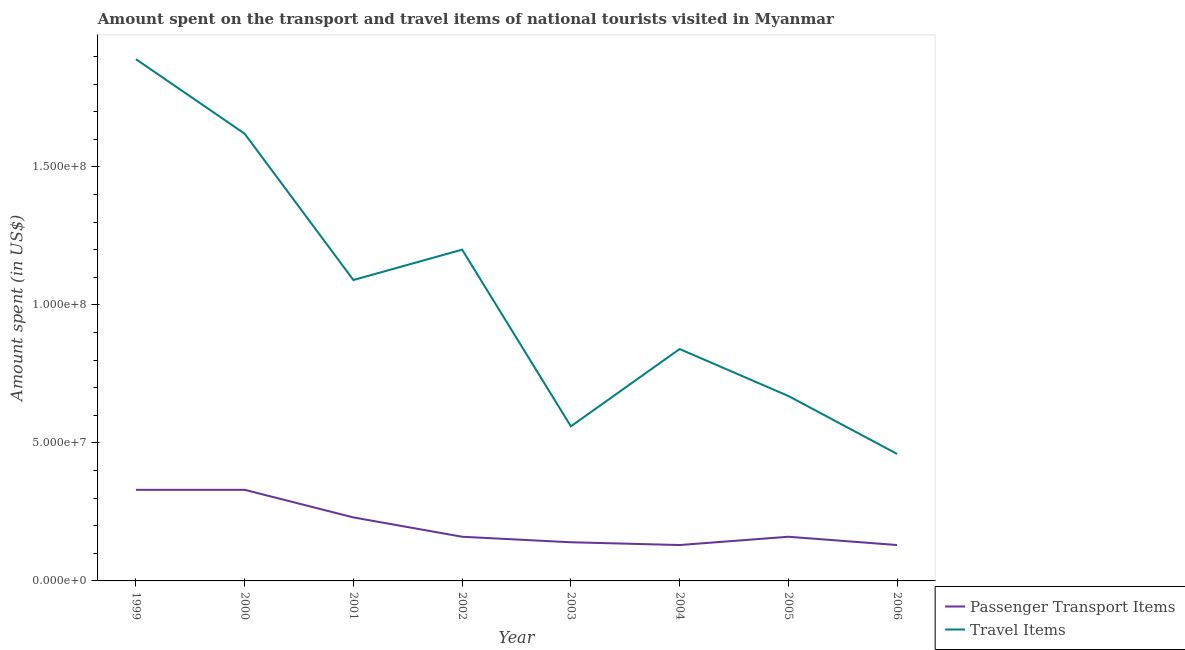How many different coloured lines are there?
Make the answer very short. 2. What is the amount spent on passenger transport items in 2006?
Provide a short and direct response. 1.30e+07. Across all years, what is the maximum amount spent in travel items?
Provide a short and direct response. 1.89e+08. Across all years, what is the minimum amount spent in travel items?
Your response must be concise. 4.60e+07. In which year was the amount spent in travel items maximum?
Keep it short and to the point. 1999. What is the total amount spent on passenger transport items in the graph?
Provide a succinct answer. 1.61e+08. What is the difference between the amount spent in travel items in 2000 and that in 2001?
Keep it short and to the point. 5.30e+07. What is the difference between the amount spent on passenger transport items in 2002 and the amount spent in travel items in 2005?
Keep it short and to the point. -5.10e+07. What is the average amount spent on passenger transport items per year?
Ensure brevity in your answer.  2.01e+07. In the year 2006, what is the difference between the amount spent on passenger transport items and amount spent in travel items?
Ensure brevity in your answer.  -3.30e+07. What is the ratio of the amount spent on passenger transport items in 1999 to that in 2006?
Make the answer very short. 2.54. Is the difference between the amount spent on passenger transport items in 2002 and 2004 greater than the difference between the amount spent in travel items in 2002 and 2004?
Ensure brevity in your answer.  No. What is the difference between the highest and the second highest amount spent in travel items?
Offer a terse response. 2.70e+07. What is the difference between the highest and the lowest amount spent on passenger transport items?
Provide a short and direct response. 2.00e+07. In how many years, is the amount spent on passenger transport items greater than the average amount spent on passenger transport items taken over all years?
Keep it short and to the point. 3. Is the sum of the amount spent on passenger transport items in 2000 and 2002 greater than the maximum amount spent in travel items across all years?
Your answer should be very brief. No. Is the amount spent on passenger transport items strictly greater than the amount spent in travel items over the years?
Your answer should be compact. No. Is the amount spent in travel items strictly less than the amount spent on passenger transport items over the years?
Make the answer very short. No. How many lines are there?
Give a very brief answer. 2. How many years are there in the graph?
Provide a short and direct response. 8. What is the difference between two consecutive major ticks on the Y-axis?
Provide a succinct answer. 5.00e+07. Does the graph contain grids?
Your answer should be compact. No. What is the title of the graph?
Your answer should be very brief. Amount spent on the transport and travel items of national tourists visited in Myanmar. What is the label or title of the Y-axis?
Offer a very short reply. Amount spent (in US$). What is the Amount spent (in US$) of Passenger Transport Items in 1999?
Make the answer very short. 3.30e+07. What is the Amount spent (in US$) of Travel Items in 1999?
Your answer should be compact. 1.89e+08. What is the Amount spent (in US$) in Passenger Transport Items in 2000?
Offer a terse response. 3.30e+07. What is the Amount spent (in US$) of Travel Items in 2000?
Provide a short and direct response. 1.62e+08. What is the Amount spent (in US$) in Passenger Transport Items in 2001?
Your answer should be very brief. 2.30e+07. What is the Amount spent (in US$) of Travel Items in 2001?
Make the answer very short. 1.09e+08. What is the Amount spent (in US$) in Passenger Transport Items in 2002?
Give a very brief answer. 1.60e+07. What is the Amount spent (in US$) in Travel Items in 2002?
Your answer should be very brief. 1.20e+08. What is the Amount spent (in US$) of Passenger Transport Items in 2003?
Give a very brief answer. 1.40e+07. What is the Amount spent (in US$) of Travel Items in 2003?
Provide a short and direct response. 5.60e+07. What is the Amount spent (in US$) in Passenger Transport Items in 2004?
Provide a short and direct response. 1.30e+07. What is the Amount spent (in US$) in Travel Items in 2004?
Your response must be concise. 8.40e+07. What is the Amount spent (in US$) of Passenger Transport Items in 2005?
Provide a succinct answer. 1.60e+07. What is the Amount spent (in US$) of Travel Items in 2005?
Your answer should be compact. 6.70e+07. What is the Amount spent (in US$) in Passenger Transport Items in 2006?
Offer a very short reply. 1.30e+07. What is the Amount spent (in US$) in Travel Items in 2006?
Provide a short and direct response. 4.60e+07. Across all years, what is the maximum Amount spent (in US$) in Passenger Transport Items?
Ensure brevity in your answer.  3.30e+07. Across all years, what is the maximum Amount spent (in US$) in Travel Items?
Your response must be concise. 1.89e+08. Across all years, what is the minimum Amount spent (in US$) of Passenger Transport Items?
Provide a short and direct response. 1.30e+07. Across all years, what is the minimum Amount spent (in US$) of Travel Items?
Your response must be concise. 4.60e+07. What is the total Amount spent (in US$) in Passenger Transport Items in the graph?
Give a very brief answer. 1.61e+08. What is the total Amount spent (in US$) of Travel Items in the graph?
Offer a terse response. 8.33e+08. What is the difference between the Amount spent (in US$) of Travel Items in 1999 and that in 2000?
Ensure brevity in your answer.  2.70e+07. What is the difference between the Amount spent (in US$) in Passenger Transport Items in 1999 and that in 2001?
Your answer should be compact. 1.00e+07. What is the difference between the Amount spent (in US$) in Travel Items in 1999 and that in 2001?
Make the answer very short. 8.00e+07. What is the difference between the Amount spent (in US$) in Passenger Transport Items in 1999 and that in 2002?
Make the answer very short. 1.70e+07. What is the difference between the Amount spent (in US$) of Travel Items in 1999 and that in 2002?
Offer a very short reply. 6.90e+07. What is the difference between the Amount spent (in US$) in Passenger Transport Items in 1999 and that in 2003?
Provide a short and direct response. 1.90e+07. What is the difference between the Amount spent (in US$) of Travel Items in 1999 and that in 2003?
Your response must be concise. 1.33e+08. What is the difference between the Amount spent (in US$) in Travel Items in 1999 and that in 2004?
Your answer should be very brief. 1.05e+08. What is the difference between the Amount spent (in US$) in Passenger Transport Items in 1999 and that in 2005?
Provide a short and direct response. 1.70e+07. What is the difference between the Amount spent (in US$) of Travel Items in 1999 and that in 2005?
Ensure brevity in your answer.  1.22e+08. What is the difference between the Amount spent (in US$) of Travel Items in 1999 and that in 2006?
Ensure brevity in your answer.  1.43e+08. What is the difference between the Amount spent (in US$) of Passenger Transport Items in 2000 and that in 2001?
Your answer should be compact. 1.00e+07. What is the difference between the Amount spent (in US$) of Travel Items in 2000 and that in 2001?
Keep it short and to the point. 5.30e+07. What is the difference between the Amount spent (in US$) in Passenger Transport Items in 2000 and that in 2002?
Your answer should be compact. 1.70e+07. What is the difference between the Amount spent (in US$) in Travel Items in 2000 and that in 2002?
Make the answer very short. 4.20e+07. What is the difference between the Amount spent (in US$) in Passenger Transport Items in 2000 and that in 2003?
Offer a terse response. 1.90e+07. What is the difference between the Amount spent (in US$) in Travel Items in 2000 and that in 2003?
Keep it short and to the point. 1.06e+08. What is the difference between the Amount spent (in US$) of Passenger Transport Items in 2000 and that in 2004?
Make the answer very short. 2.00e+07. What is the difference between the Amount spent (in US$) in Travel Items in 2000 and that in 2004?
Offer a terse response. 7.80e+07. What is the difference between the Amount spent (in US$) of Passenger Transport Items in 2000 and that in 2005?
Give a very brief answer. 1.70e+07. What is the difference between the Amount spent (in US$) in Travel Items in 2000 and that in 2005?
Make the answer very short. 9.50e+07. What is the difference between the Amount spent (in US$) of Travel Items in 2000 and that in 2006?
Offer a terse response. 1.16e+08. What is the difference between the Amount spent (in US$) of Travel Items in 2001 and that in 2002?
Offer a very short reply. -1.10e+07. What is the difference between the Amount spent (in US$) of Passenger Transport Items in 2001 and that in 2003?
Give a very brief answer. 9.00e+06. What is the difference between the Amount spent (in US$) in Travel Items in 2001 and that in 2003?
Offer a very short reply. 5.30e+07. What is the difference between the Amount spent (in US$) of Passenger Transport Items in 2001 and that in 2004?
Provide a succinct answer. 1.00e+07. What is the difference between the Amount spent (in US$) of Travel Items in 2001 and that in 2004?
Make the answer very short. 2.50e+07. What is the difference between the Amount spent (in US$) of Travel Items in 2001 and that in 2005?
Offer a very short reply. 4.20e+07. What is the difference between the Amount spent (in US$) of Travel Items in 2001 and that in 2006?
Provide a short and direct response. 6.30e+07. What is the difference between the Amount spent (in US$) in Passenger Transport Items in 2002 and that in 2003?
Give a very brief answer. 2.00e+06. What is the difference between the Amount spent (in US$) in Travel Items in 2002 and that in 2003?
Provide a succinct answer. 6.40e+07. What is the difference between the Amount spent (in US$) in Travel Items in 2002 and that in 2004?
Provide a short and direct response. 3.60e+07. What is the difference between the Amount spent (in US$) of Passenger Transport Items in 2002 and that in 2005?
Give a very brief answer. 0. What is the difference between the Amount spent (in US$) in Travel Items in 2002 and that in 2005?
Your answer should be very brief. 5.30e+07. What is the difference between the Amount spent (in US$) of Travel Items in 2002 and that in 2006?
Your answer should be compact. 7.40e+07. What is the difference between the Amount spent (in US$) of Travel Items in 2003 and that in 2004?
Provide a succinct answer. -2.80e+07. What is the difference between the Amount spent (in US$) of Travel Items in 2003 and that in 2005?
Offer a terse response. -1.10e+07. What is the difference between the Amount spent (in US$) of Passenger Transport Items in 2004 and that in 2005?
Provide a succinct answer. -3.00e+06. What is the difference between the Amount spent (in US$) of Travel Items in 2004 and that in 2005?
Your answer should be very brief. 1.70e+07. What is the difference between the Amount spent (in US$) in Travel Items in 2004 and that in 2006?
Keep it short and to the point. 3.80e+07. What is the difference between the Amount spent (in US$) in Passenger Transport Items in 2005 and that in 2006?
Keep it short and to the point. 3.00e+06. What is the difference between the Amount spent (in US$) in Travel Items in 2005 and that in 2006?
Ensure brevity in your answer.  2.10e+07. What is the difference between the Amount spent (in US$) of Passenger Transport Items in 1999 and the Amount spent (in US$) of Travel Items in 2000?
Provide a short and direct response. -1.29e+08. What is the difference between the Amount spent (in US$) in Passenger Transport Items in 1999 and the Amount spent (in US$) in Travel Items in 2001?
Provide a succinct answer. -7.60e+07. What is the difference between the Amount spent (in US$) in Passenger Transport Items in 1999 and the Amount spent (in US$) in Travel Items in 2002?
Provide a succinct answer. -8.70e+07. What is the difference between the Amount spent (in US$) in Passenger Transport Items in 1999 and the Amount spent (in US$) in Travel Items in 2003?
Make the answer very short. -2.30e+07. What is the difference between the Amount spent (in US$) of Passenger Transport Items in 1999 and the Amount spent (in US$) of Travel Items in 2004?
Make the answer very short. -5.10e+07. What is the difference between the Amount spent (in US$) in Passenger Transport Items in 1999 and the Amount spent (in US$) in Travel Items in 2005?
Ensure brevity in your answer.  -3.40e+07. What is the difference between the Amount spent (in US$) in Passenger Transport Items in 1999 and the Amount spent (in US$) in Travel Items in 2006?
Your response must be concise. -1.30e+07. What is the difference between the Amount spent (in US$) in Passenger Transport Items in 2000 and the Amount spent (in US$) in Travel Items in 2001?
Make the answer very short. -7.60e+07. What is the difference between the Amount spent (in US$) in Passenger Transport Items in 2000 and the Amount spent (in US$) in Travel Items in 2002?
Provide a short and direct response. -8.70e+07. What is the difference between the Amount spent (in US$) of Passenger Transport Items in 2000 and the Amount spent (in US$) of Travel Items in 2003?
Provide a succinct answer. -2.30e+07. What is the difference between the Amount spent (in US$) of Passenger Transport Items in 2000 and the Amount spent (in US$) of Travel Items in 2004?
Your response must be concise. -5.10e+07. What is the difference between the Amount spent (in US$) of Passenger Transport Items in 2000 and the Amount spent (in US$) of Travel Items in 2005?
Give a very brief answer. -3.40e+07. What is the difference between the Amount spent (in US$) in Passenger Transport Items in 2000 and the Amount spent (in US$) in Travel Items in 2006?
Your response must be concise. -1.30e+07. What is the difference between the Amount spent (in US$) in Passenger Transport Items in 2001 and the Amount spent (in US$) in Travel Items in 2002?
Your answer should be very brief. -9.70e+07. What is the difference between the Amount spent (in US$) in Passenger Transport Items in 2001 and the Amount spent (in US$) in Travel Items in 2003?
Your answer should be compact. -3.30e+07. What is the difference between the Amount spent (in US$) of Passenger Transport Items in 2001 and the Amount spent (in US$) of Travel Items in 2004?
Provide a succinct answer. -6.10e+07. What is the difference between the Amount spent (in US$) of Passenger Transport Items in 2001 and the Amount spent (in US$) of Travel Items in 2005?
Make the answer very short. -4.40e+07. What is the difference between the Amount spent (in US$) of Passenger Transport Items in 2001 and the Amount spent (in US$) of Travel Items in 2006?
Offer a terse response. -2.30e+07. What is the difference between the Amount spent (in US$) of Passenger Transport Items in 2002 and the Amount spent (in US$) of Travel Items in 2003?
Your response must be concise. -4.00e+07. What is the difference between the Amount spent (in US$) in Passenger Transport Items in 2002 and the Amount spent (in US$) in Travel Items in 2004?
Offer a very short reply. -6.80e+07. What is the difference between the Amount spent (in US$) of Passenger Transport Items in 2002 and the Amount spent (in US$) of Travel Items in 2005?
Offer a very short reply. -5.10e+07. What is the difference between the Amount spent (in US$) in Passenger Transport Items in 2002 and the Amount spent (in US$) in Travel Items in 2006?
Offer a terse response. -3.00e+07. What is the difference between the Amount spent (in US$) in Passenger Transport Items in 2003 and the Amount spent (in US$) in Travel Items in 2004?
Offer a terse response. -7.00e+07. What is the difference between the Amount spent (in US$) of Passenger Transport Items in 2003 and the Amount spent (in US$) of Travel Items in 2005?
Give a very brief answer. -5.30e+07. What is the difference between the Amount spent (in US$) in Passenger Transport Items in 2003 and the Amount spent (in US$) in Travel Items in 2006?
Keep it short and to the point. -3.20e+07. What is the difference between the Amount spent (in US$) of Passenger Transport Items in 2004 and the Amount spent (in US$) of Travel Items in 2005?
Provide a short and direct response. -5.40e+07. What is the difference between the Amount spent (in US$) of Passenger Transport Items in 2004 and the Amount spent (in US$) of Travel Items in 2006?
Provide a short and direct response. -3.30e+07. What is the difference between the Amount spent (in US$) in Passenger Transport Items in 2005 and the Amount spent (in US$) in Travel Items in 2006?
Your response must be concise. -3.00e+07. What is the average Amount spent (in US$) in Passenger Transport Items per year?
Provide a succinct answer. 2.01e+07. What is the average Amount spent (in US$) in Travel Items per year?
Give a very brief answer. 1.04e+08. In the year 1999, what is the difference between the Amount spent (in US$) in Passenger Transport Items and Amount spent (in US$) in Travel Items?
Your response must be concise. -1.56e+08. In the year 2000, what is the difference between the Amount spent (in US$) in Passenger Transport Items and Amount spent (in US$) in Travel Items?
Provide a succinct answer. -1.29e+08. In the year 2001, what is the difference between the Amount spent (in US$) in Passenger Transport Items and Amount spent (in US$) in Travel Items?
Your response must be concise. -8.60e+07. In the year 2002, what is the difference between the Amount spent (in US$) of Passenger Transport Items and Amount spent (in US$) of Travel Items?
Keep it short and to the point. -1.04e+08. In the year 2003, what is the difference between the Amount spent (in US$) in Passenger Transport Items and Amount spent (in US$) in Travel Items?
Offer a terse response. -4.20e+07. In the year 2004, what is the difference between the Amount spent (in US$) in Passenger Transport Items and Amount spent (in US$) in Travel Items?
Give a very brief answer. -7.10e+07. In the year 2005, what is the difference between the Amount spent (in US$) in Passenger Transport Items and Amount spent (in US$) in Travel Items?
Your response must be concise. -5.10e+07. In the year 2006, what is the difference between the Amount spent (in US$) of Passenger Transport Items and Amount spent (in US$) of Travel Items?
Your answer should be very brief. -3.30e+07. What is the ratio of the Amount spent (in US$) of Passenger Transport Items in 1999 to that in 2001?
Offer a very short reply. 1.43. What is the ratio of the Amount spent (in US$) of Travel Items in 1999 to that in 2001?
Make the answer very short. 1.73. What is the ratio of the Amount spent (in US$) of Passenger Transport Items in 1999 to that in 2002?
Your answer should be very brief. 2.06. What is the ratio of the Amount spent (in US$) in Travel Items in 1999 to that in 2002?
Offer a terse response. 1.57. What is the ratio of the Amount spent (in US$) in Passenger Transport Items in 1999 to that in 2003?
Keep it short and to the point. 2.36. What is the ratio of the Amount spent (in US$) in Travel Items in 1999 to that in 2003?
Provide a succinct answer. 3.38. What is the ratio of the Amount spent (in US$) of Passenger Transport Items in 1999 to that in 2004?
Keep it short and to the point. 2.54. What is the ratio of the Amount spent (in US$) of Travel Items in 1999 to that in 2004?
Keep it short and to the point. 2.25. What is the ratio of the Amount spent (in US$) of Passenger Transport Items in 1999 to that in 2005?
Your response must be concise. 2.06. What is the ratio of the Amount spent (in US$) in Travel Items in 1999 to that in 2005?
Ensure brevity in your answer.  2.82. What is the ratio of the Amount spent (in US$) in Passenger Transport Items in 1999 to that in 2006?
Your answer should be compact. 2.54. What is the ratio of the Amount spent (in US$) in Travel Items in 1999 to that in 2006?
Your answer should be compact. 4.11. What is the ratio of the Amount spent (in US$) in Passenger Transport Items in 2000 to that in 2001?
Give a very brief answer. 1.43. What is the ratio of the Amount spent (in US$) in Travel Items in 2000 to that in 2001?
Ensure brevity in your answer.  1.49. What is the ratio of the Amount spent (in US$) in Passenger Transport Items in 2000 to that in 2002?
Your answer should be very brief. 2.06. What is the ratio of the Amount spent (in US$) of Travel Items in 2000 to that in 2002?
Provide a short and direct response. 1.35. What is the ratio of the Amount spent (in US$) of Passenger Transport Items in 2000 to that in 2003?
Offer a terse response. 2.36. What is the ratio of the Amount spent (in US$) in Travel Items in 2000 to that in 2003?
Offer a terse response. 2.89. What is the ratio of the Amount spent (in US$) in Passenger Transport Items in 2000 to that in 2004?
Provide a short and direct response. 2.54. What is the ratio of the Amount spent (in US$) of Travel Items in 2000 to that in 2004?
Your answer should be compact. 1.93. What is the ratio of the Amount spent (in US$) in Passenger Transport Items in 2000 to that in 2005?
Your answer should be very brief. 2.06. What is the ratio of the Amount spent (in US$) of Travel Items in 2000 to that in 2005?
Keep it short and to the point. 2.42. What is the ratio of the Amount spent (in US$) of Passenger Transport Items in 2000 to that in 2006?
Offer a terse response. 2.54. What is the ratio of the Amount spent (in US$) of Travel Items in 2000 to that in 2006?
Ensure brevity in your answer.  3.52. What is the ratio of the Amount spent (in US$) in Passenger Transport Items in 2001 to that in 2002?
Your response must be concise. 1.44. What is the ratio of the Amount spent (in US$) of Travel Items in 2001 to that in 2002?
Offer a terse response. 0.91. What is the ratio of the Amount spent (in US$) of Passenger Transport Items in 2001 to that in 2003?
Make the answer very short. 1.64. What is the ratio of the Amount spent (in US$) in Travel Items in 2001 to that in 2003?
Provide a short and direct response. 1.95. What is the ratio of the Amount spent (in US$) in Passenger Transport Items in 2001 to that in 2004?
Your response must be concise. 1.77. What is the ratio of the Amount spent (in US$) in Travel Items in 2001 to that in 2004?
Your answer should be compact. 1.3. What is the ratio of the Amount spent (in US$) in Passenger Transport Items in 2001 to that in 2005?
Your answer should be very brief. 1.44. What is the ratio of the Amount spent (in US$) in Travel Items in 2001 to that in 2005?
Offer a terse response. 1.63. What is the ratio of the Amount spent (in US$) of Passenger Transport Items in 2001 to that in 2006?
Provide a short and direct response. 1.77. What is the ratio of the Amount spent (in US$) in Travel Items in 2001 to that in 2006?
Offer a terse response. 2.37. What is the ratio of the Amount spent (in US$) of Travel Items in 2002 to that in 2003?
Provide a short and direct response. 2.14. What is the ratio of the Amount spent (in US$) in Passenger Transport Items in 2002 to that in 2004?
Offer a terse response. 1.23. What is the ratio of the Amount spent (in US$) of Travel Items in 2002 to that in 2004?
Provide a short and direct response. 1.43. What is the ratio of the Amount spent (in US$) of Travel Items in 2002 to that in 2005?
Your answer should be very brief. 1.79. What is the ratio of the Amount spent (in US$) of Passenger Transport Items in 2002 to that in 2006?
Your answer should be compact. 1.23. What is the ratio of the Amount spent (in US$) of Travel Items in 2002 to that in 2006?
Offer a very short reply. 2.61. What is the ratio of the Amount spent (in US$) in Passenger Transport Items in 2003 to that in 2004?
Your answer should be compact. 1.08. What is the ratio of the Amount spent (in US$) in Travel Items in 2003 to that in 2005?
Your response must be concise. 0.84. What is the ratio of the Amount spent (in US$) of Travel Items in 2003 to that in 2006?
Your response must be concise. 1.22. What is the ratio of the Amount spent (in US$) in Passenger Transport Items in 2004 to that in 2005?
Make the answer very short. 0.81. What is the ratio of the Amount spent (in US$) in Travel Items in 2004 to that in 2005?
Offer a terse response. 1.25. What is the ratio of the Amount spent (in US$) in Passenger Transport Items in 2004 to that in 2006?
Make the answer very short. 1. What is the ratio of the Amount spent (in US$) of Travel Items in 2004 to that in 2006?
Your answer should be very brief. 1.83. What is the ratio of the Amount spent (in US$) in Passenger Transport Items in 2005 to that in 2006?
Your answer should be very brief. 1.23. What is the ratio of the Amount spent (in US$) of Travel Items in 2005 to that in 2006?
Provide a succinct answer. 1.46. What is the difference between the highest and the second highest Amount spent (in US$) of Passenger Transport Items?
Ensure brevity in your answer.  0. What is the difference between the highest and the second highest Amount spent (in US$) in Travel Items?
Your response must be concise. 2.70e+07. What is the difference between the highest and the lowest Amount spent (in US$) in Travel Items?
Your answer should be compact. 1.43e+08. 